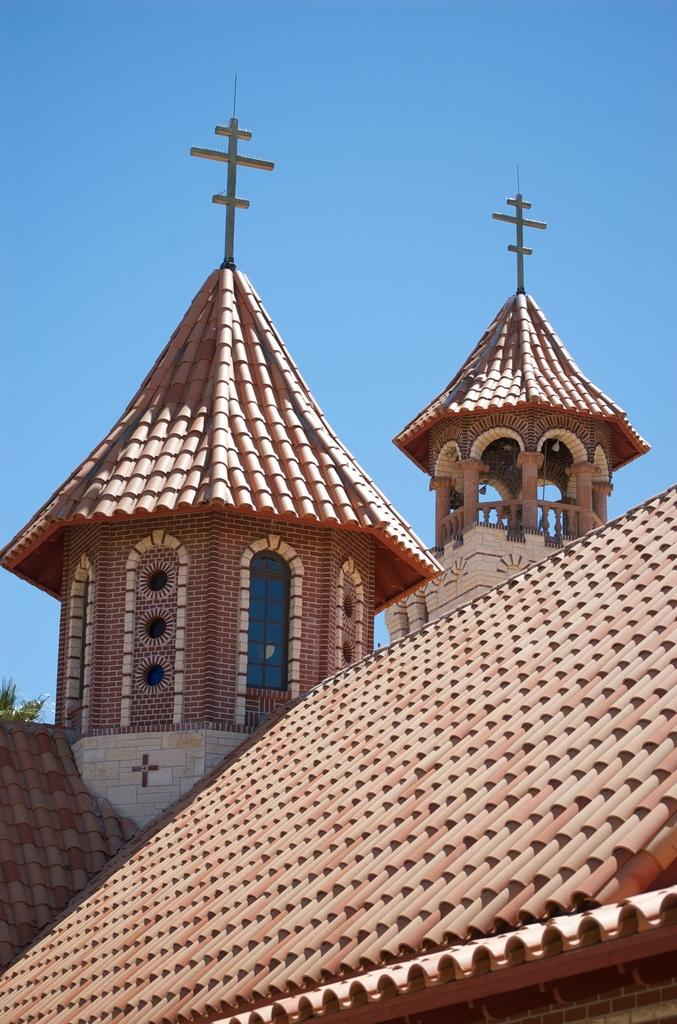What type of structure is present in the image? There is a building in the image. What architectural features can be seen on the building? The building has arches, pillars, windows, and railings. What is visible in the background of the image? The sky is visible in the background of the image. What type of curve can be seen in the notebook in the image? There is no notebook present in the image, so it is not possible to determine if there is any curve in it. 